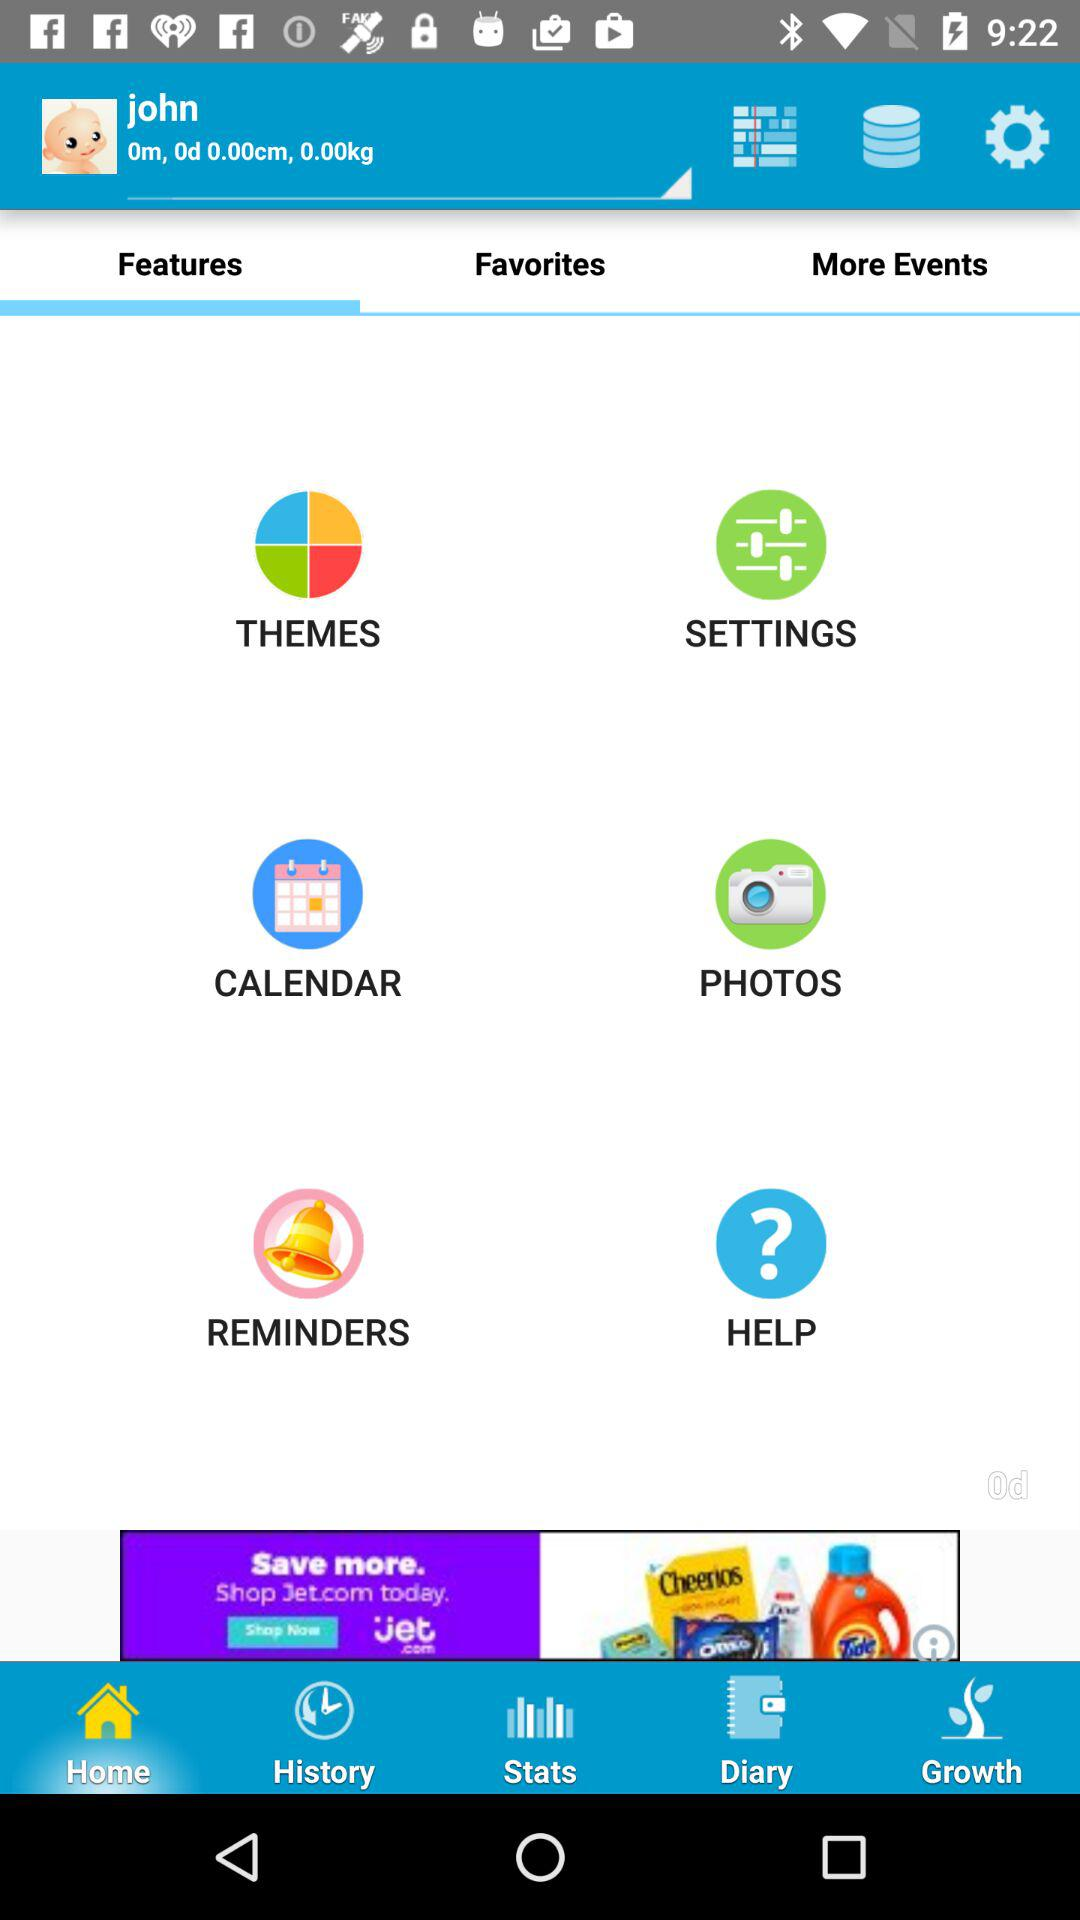What's the weight of the baby? The weight of the baby is 0 kg. 